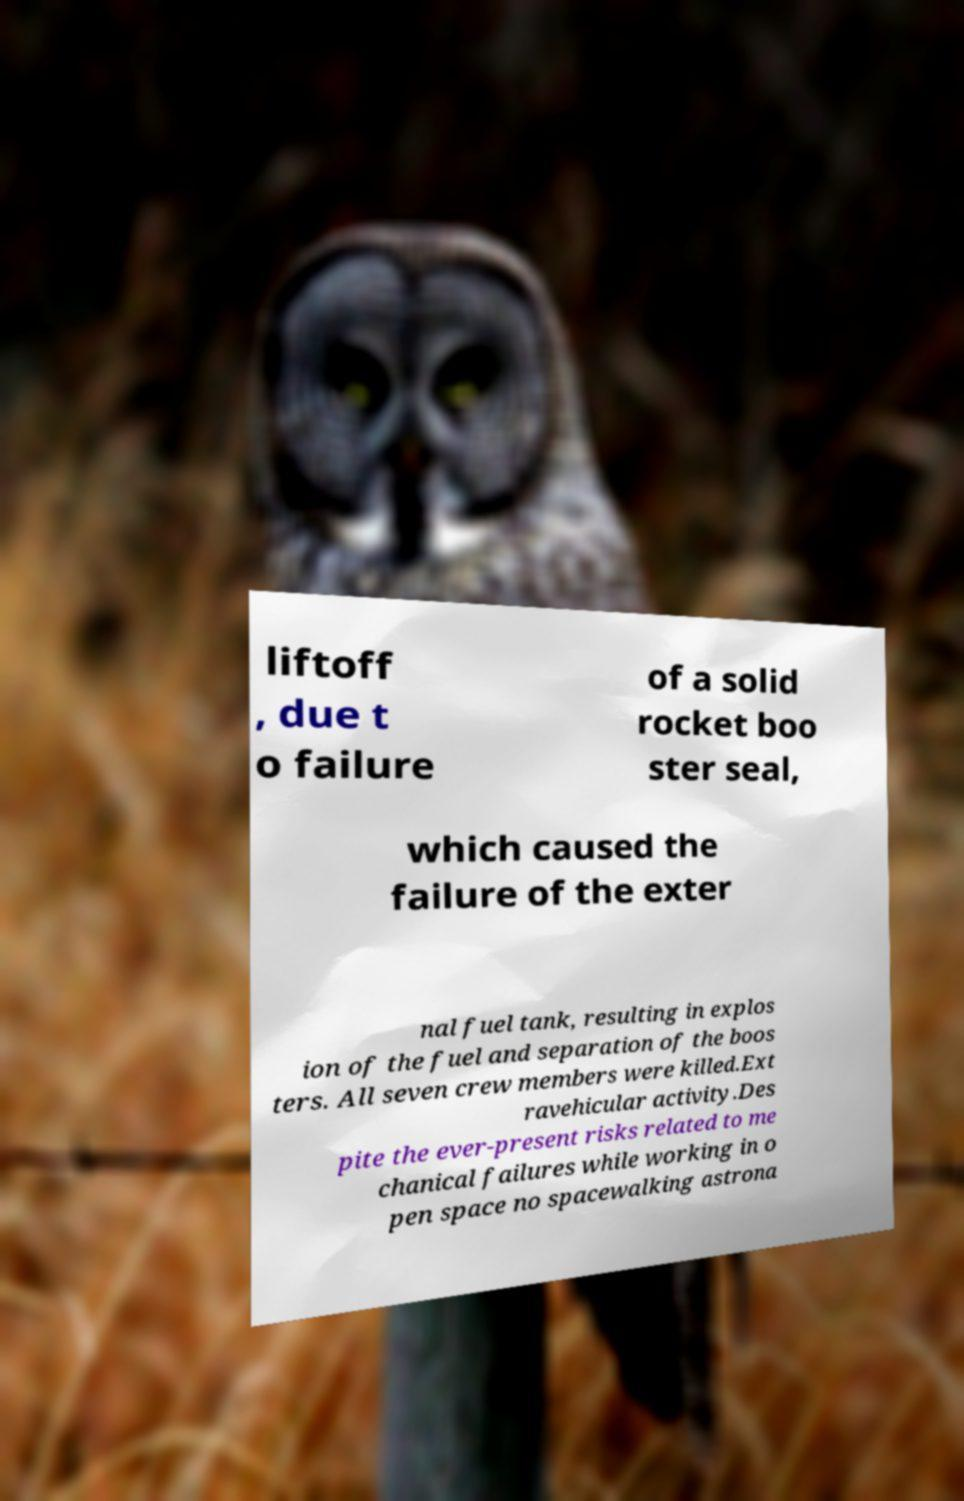For documentation purposes, I need the text within this image transcribed. Could you provide that? liftoff , due t o failure of a solid rocket boo ster seal, which caused the failure of the exter nal fuel tank, resulting in explos ion of the fuel and separation of the boos ters. All seven crew members were killed.Ext ravehicular activity.Des pite the ever-present risks related to me chanical failures while working in o pen space no spacewalking astrona 